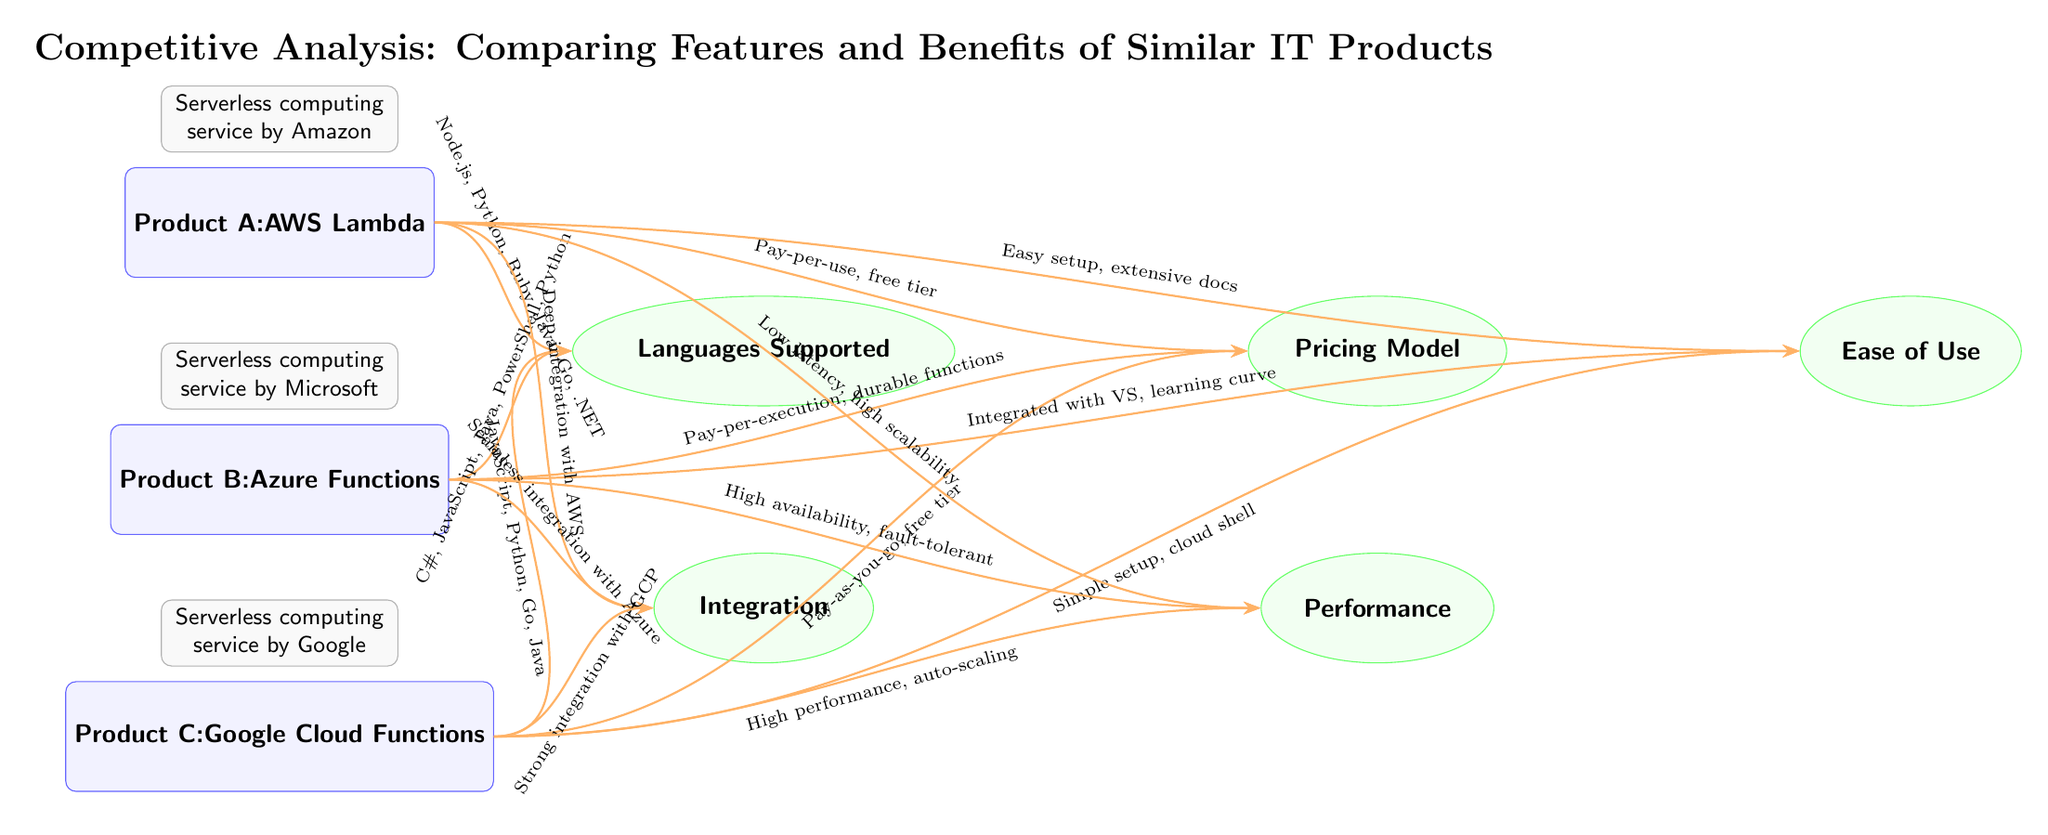What is the first product listed in the diagram? The first product listed is at the top position in the diagram under the label "Product A". It shows "AWS Lambda".
Answer: AWS Lambda Which programming languages are supported by Product C? To find which languages are supported by Product C, look at the connection from Product C to the "Languages Supported" feature, which states "JavaScript, Python, Go, Java".
Answer: JavaScript, Python, Go, Java How many products are compared in this diagram? The total number of products is calculated by counting the nodes under the product category: Product A, Product B, and Product C, totaling three products.
Answer: 3 What is the pricing model for Product B? The pricing model for Product B can be determined by following the connection from Product B to the "Pricing Model" feature, which mentions "Pay-per-execution, durable functions".
Answer: Pay-per-execution, durable functions Which product has a feature of "Deep integration with AWS"? The feature of "Deep integration with AWS" can be traced back to the connection from Product A to the "Integration" feature, indicating that this feature is associated specifically with Product A.
Answer: Product A Which product is associated with "High availability, fault-tolerant" performance? To determine which product has this performance characteristic, trace the connection from Product B to the "Performance" feature, which highlights this quality.
Answer: Product B How many features are listed in total in the diagram? The total number of features can be found by counting all the feature nodes in the diagram: "Languages Supported," "Pricing Model," "Ease of Use," "Integration," and "Performance," resulting in five features.
Answer: 5 What is the ease of use description for Product A? To find the ease of use description for Product A, follow its connection to the "Ease of Use" feature, which notes "Easy setup, extensive docs."
Answer: Easy setup, extensive docs Which product has "Strong integration with GCP"? The connection leading to "Strong integration with GCP" originates from Product C, linking it directly to that feature in the diagram.
Answer: Product C 